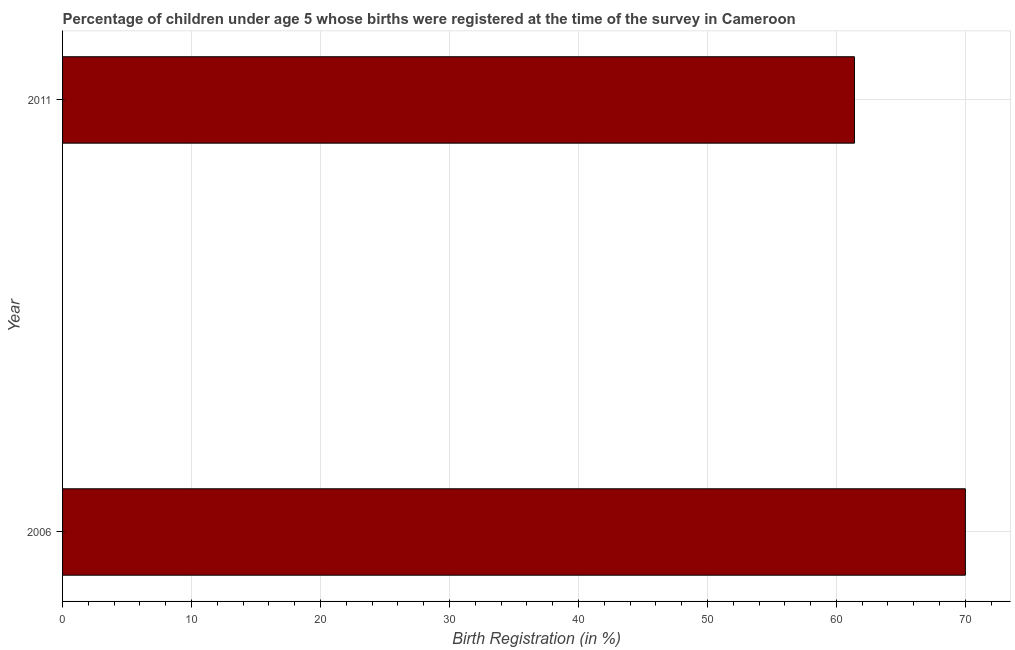Does the graph contain grids?
Your response must be concise. Yes. What is the title of the graph?
Your answer should be compact. Percentage of children under age 5 whose births were registered at the time of the survey in Cameroon. What is the label or title of the X-axis?
Ensure brevity in your answer.  Birth Registration (in %). What is the birth registration in 2006?
Your answer should be very brief. 70. Across all years, what is the maximum birth registration?
Your answer should be compact. 70. Across all years, what is the minimum birth registration?
Your response must be concise. 61.4. In which year was the birth registration maximum?
Your response must be concise. 2006. What is the sum of the birth registration?
Offer a terse response. 131.4. What is the average birth registration per year?
Offer a terse response. 65.7. What is the median birth registration?
Make the answer very short. 65.7. In how many years, is the birth registration greater than 54 %?
Keep it short and to the point. 2. What is the ratio of the birth registration in 2006 to that in 2011?
Ensure brevity in your answer.  1.14. Is the birth registration in 2006 less than that in 2011?
Your answer should be compact. No. Are all the bars in the graph horizontal?
Make the answer very short. Yes. How many years are there in the graph?
Offer a very short reply. 2. What is the difference between two consecutive major ticks on the X-axis?
Your response must be concise. 10. What is the Birth Registration (in %) in 2006?
Your response must be concise. 70. What is the Birth Registration (in %) in 2011?
Offer a very short reply. 61.4. What is the difference between the Birth Registration (in %) in 2006 and 2011?
Provide a short and direct response. 8.6. What is the ratio of the Birth Registration (in %) in 2006 to that in 2011?
Provide a succinct answer. 1.14. 